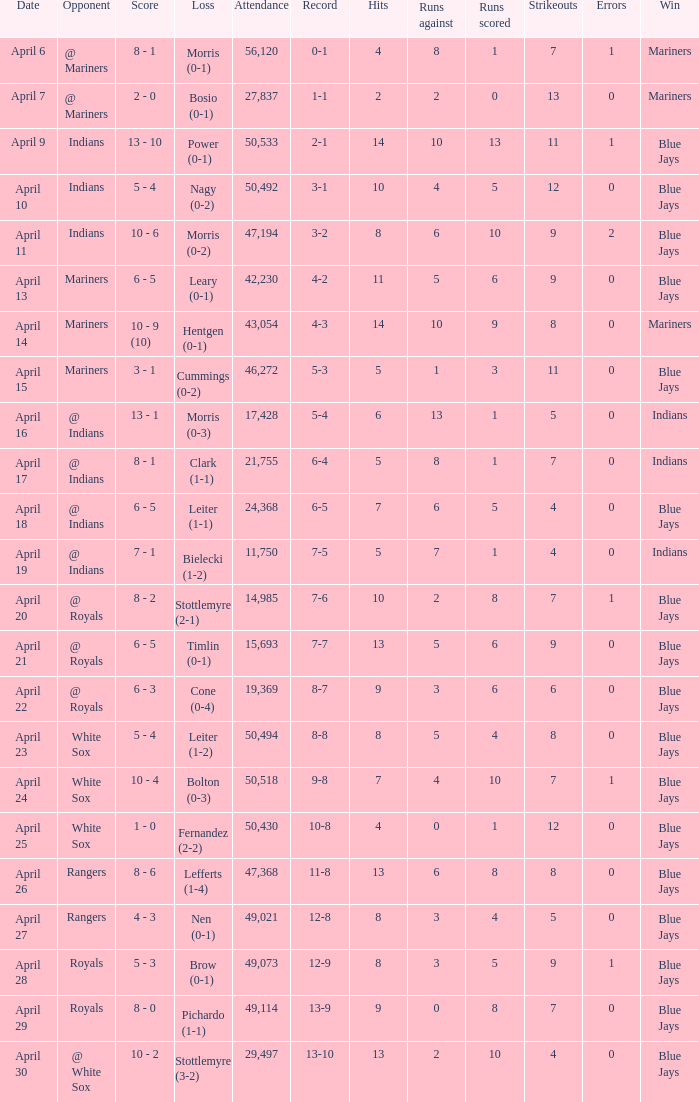What scored is recorded on April 24? 10 - 4. 